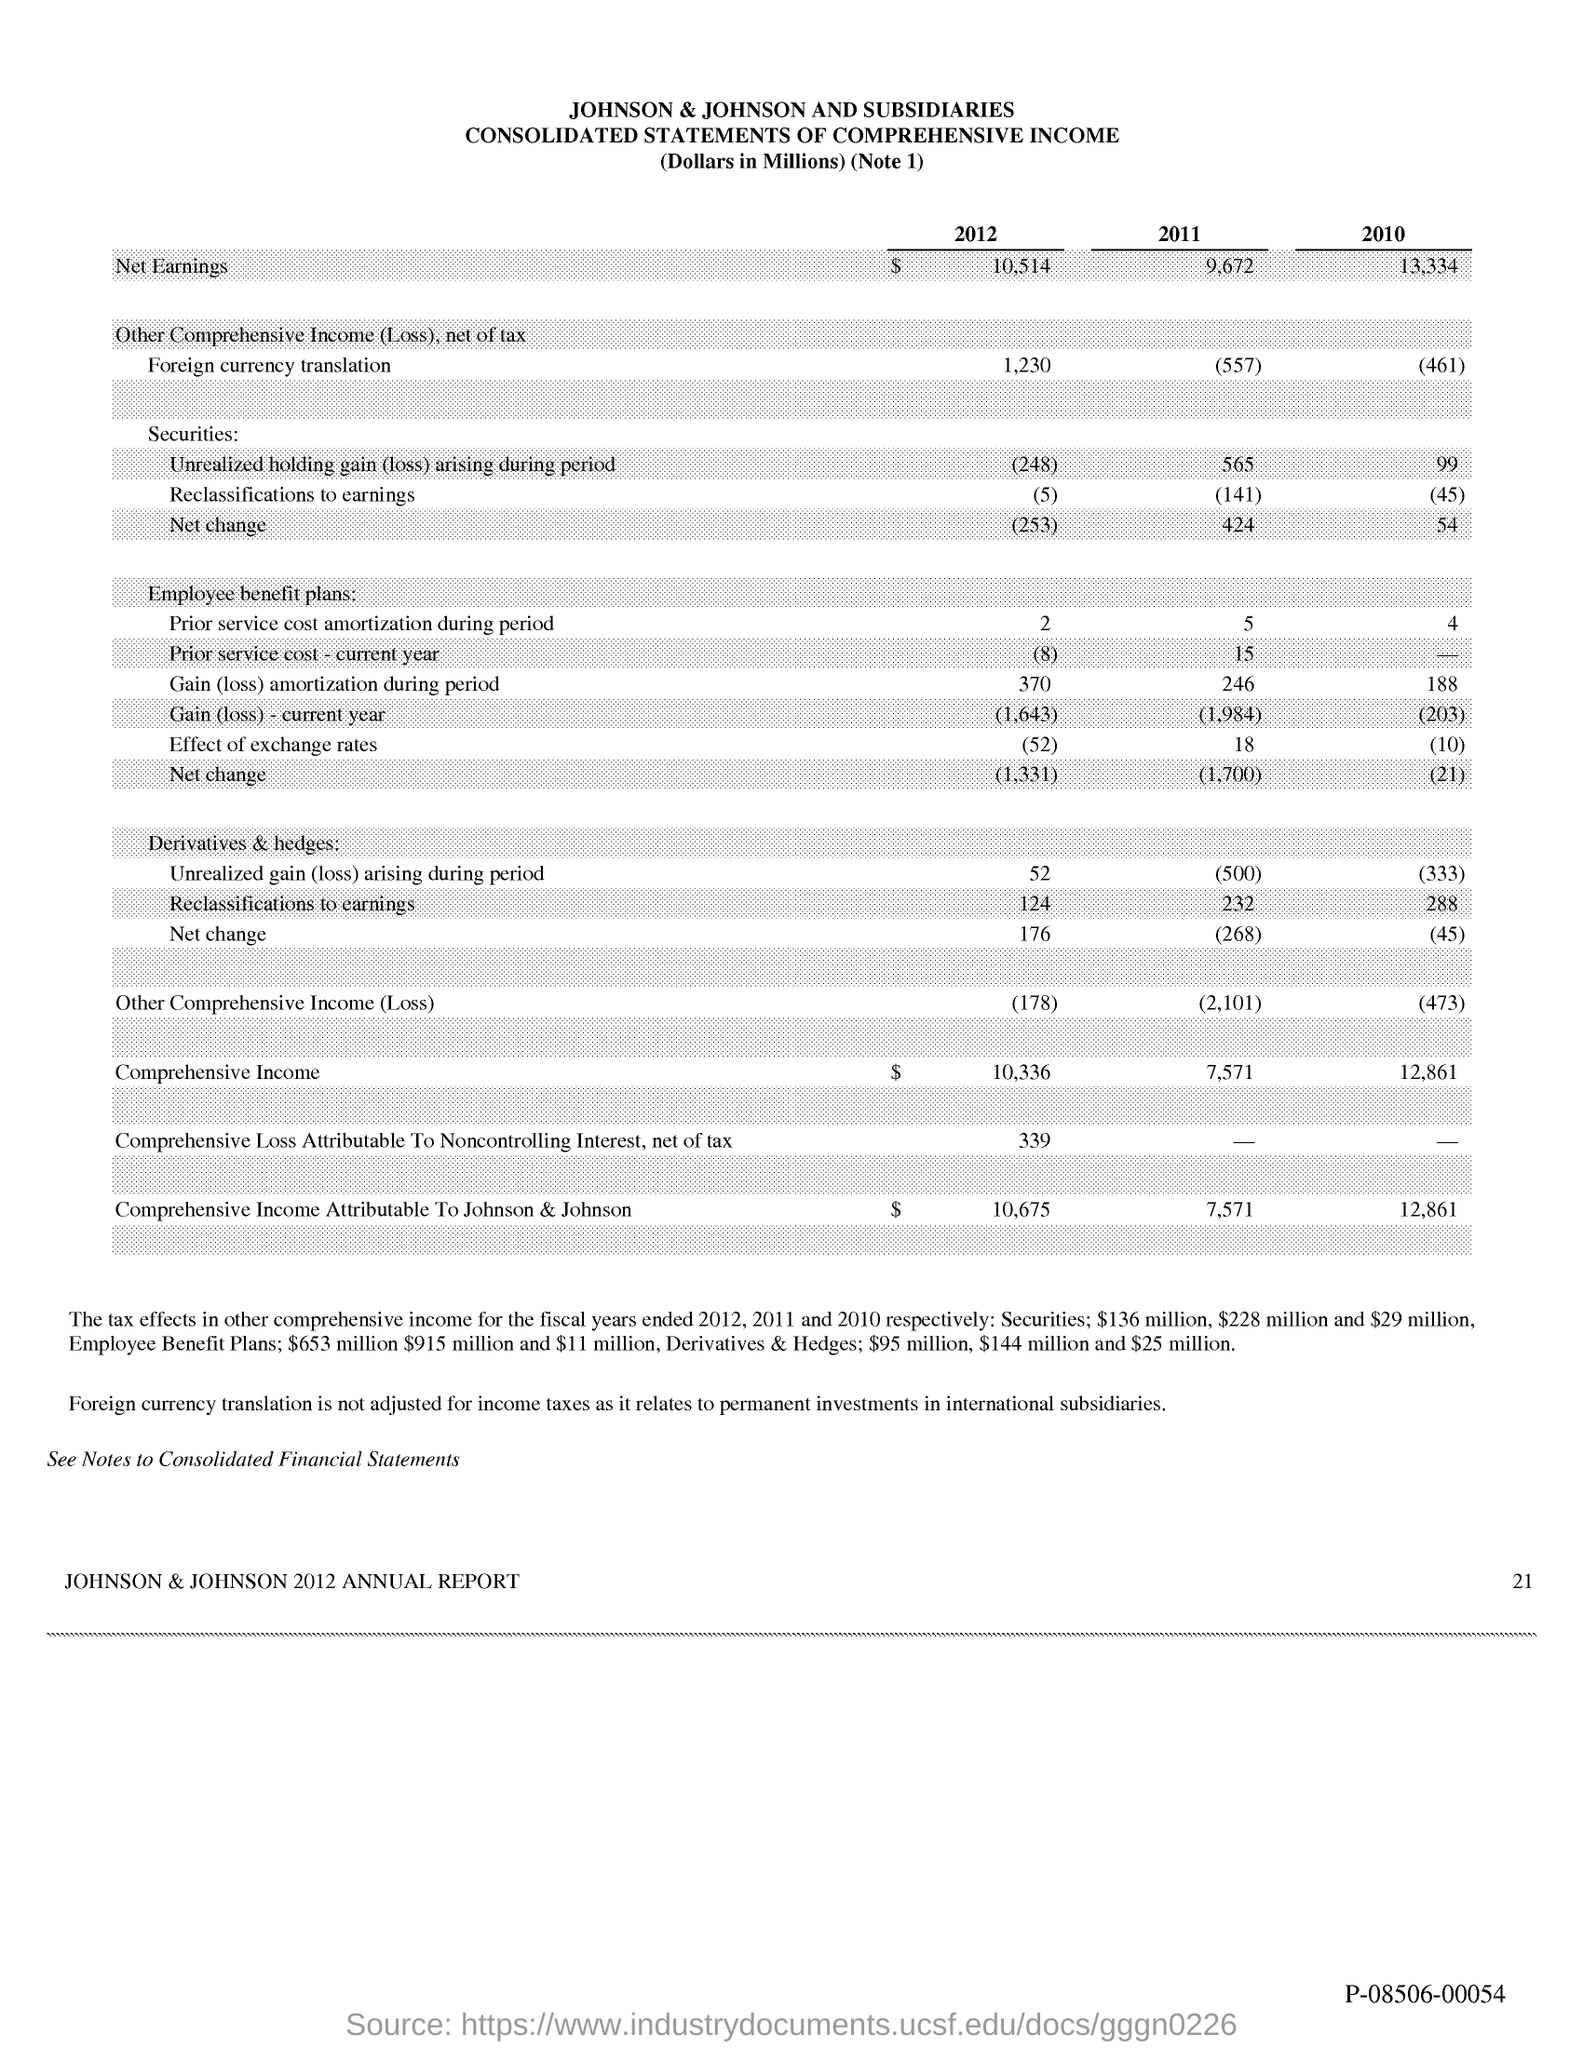Identify some key points in this picture. The page number is 21. 